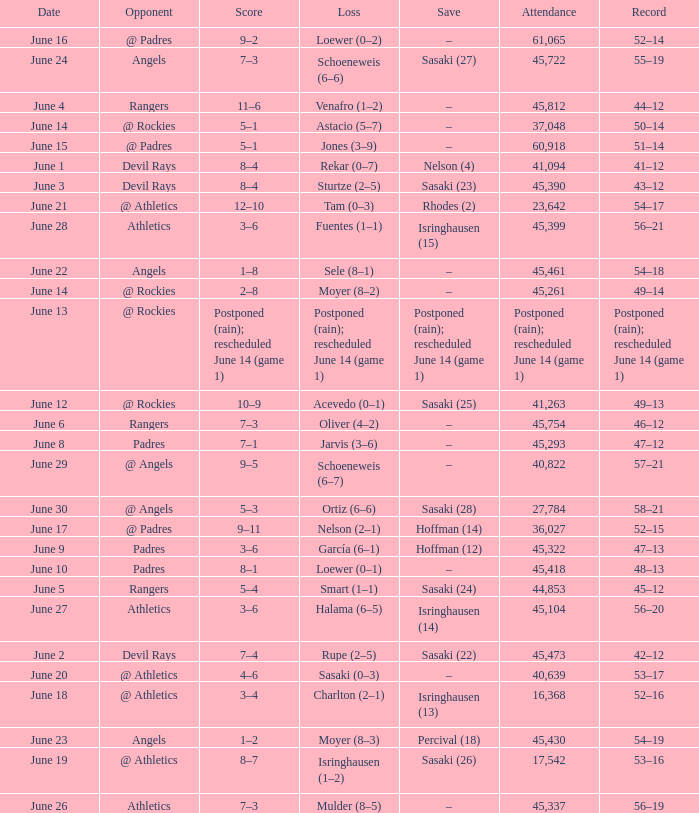What was the attendance of the Mariners game when they had a record of 56–20? 45104.0. 